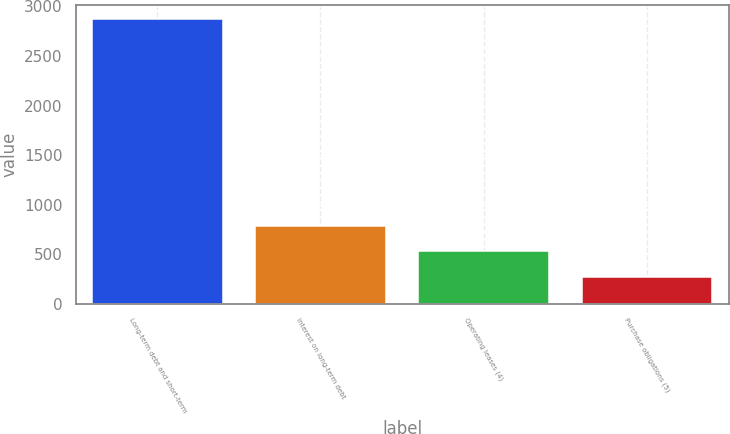<chart> <loc_0><loc_0><loc_500><loc_500><bar_chart><fcel>Long-term debt and short-term<fcel>Interest on long-term debt<fcel>Operating leases (4)<fcel>Purchase obligations (5)<nl><fcel>2870<fcel>790<fcel>530<fcel>270<nl></chart> 